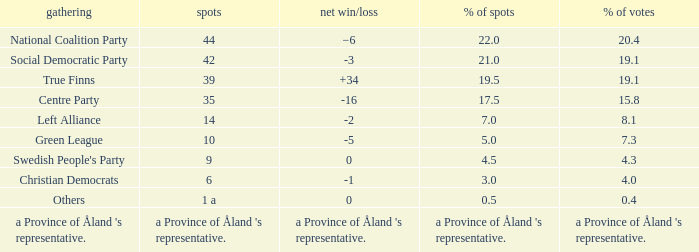When there was a net gain/loss of +34, what was the percentage of seats that party held? 19.5. 